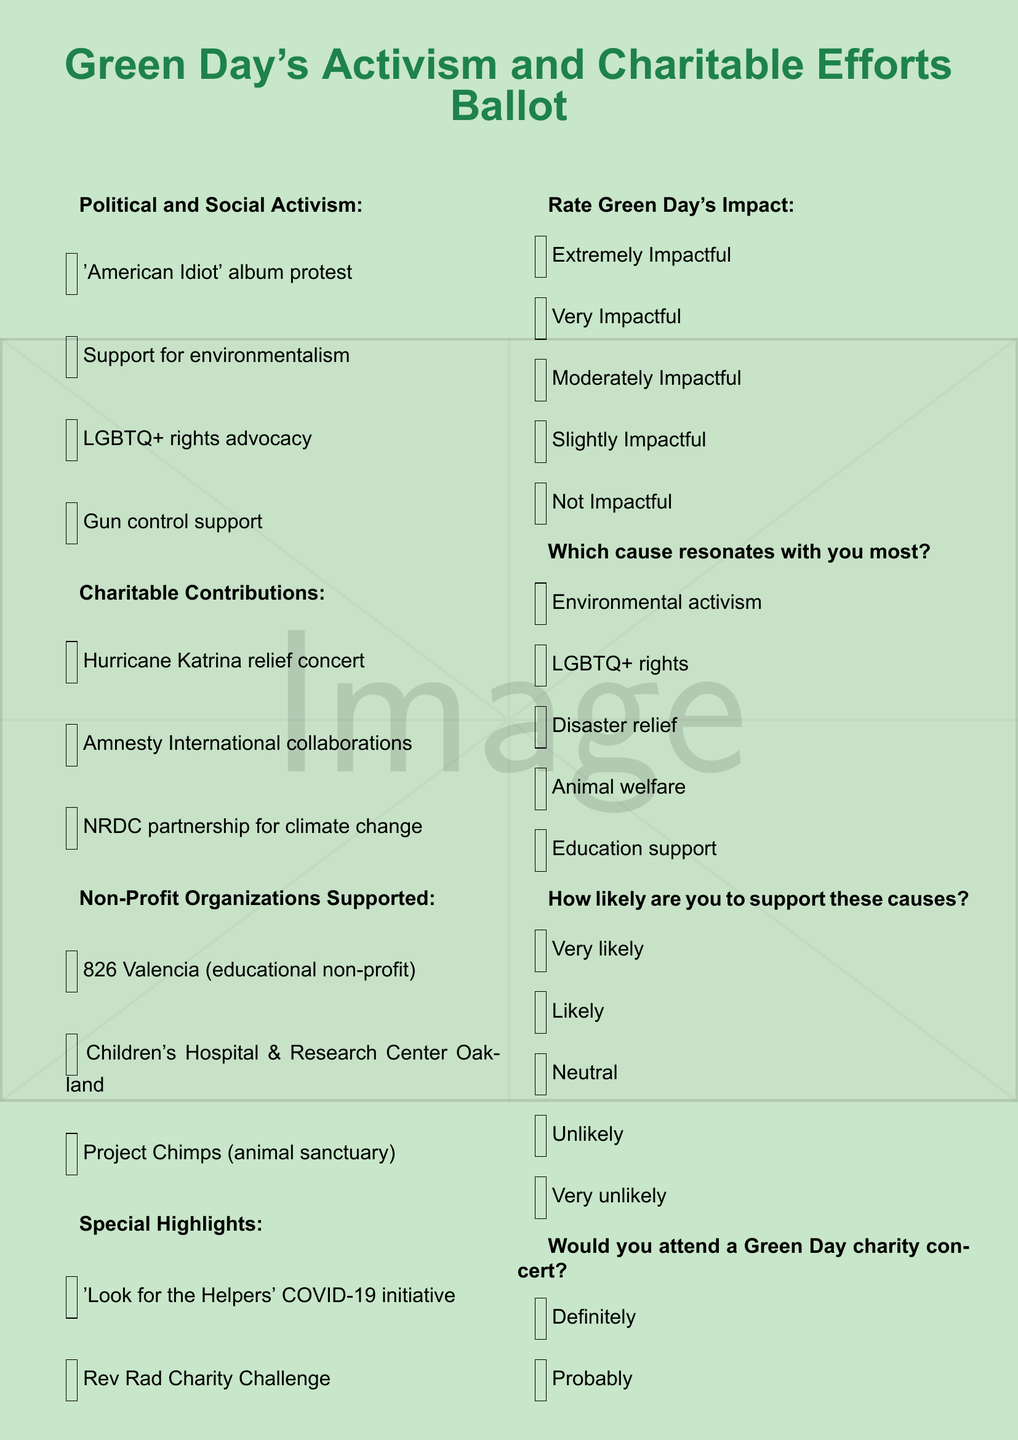What is the title of the document? The title is presented at the top of the document, indicating the primary focus on Green Day's activism and charitable efforts.
Answer: Green Day's Activism and Charitable Efforts Ballot How many non-profit organizations does Green Day support? The document lists three specific non-profit organizations under the "Non-Profit Organizations Supported" section.
Answer: 3 Which album by Green Day is mentioned in relation to protest? The document mentions a specific album in the context of political activism and protest efforts.
Answer: American Idiot What initiative did Green Day undertake during the COVID-19 pandemic? The document highlights a specific initiative launched by Green Day to address challenges during the pandemic.
Answer: Look for the Helpers What rating option indicates the highest perceived impact of Green Day's activism? The ballot provides several rating options for people to evaluate the band's impact, starting with the most impactful.
Answer: Extremely Impactful How many categories of contributions are highlighted in the ballot? The document organizes the contributions into distinct categories which provide clarity on Green Day's activism and charitable actions.
Answer: 4 Which cause is listed under "Which cause resonates with you most?" The document provides a selection of causes, presenting them to the reader for consideration based on personal resonance.
Answer: Environmental activism What is the lowest likelihood response option for supporting causes? The document outlines a series of likelihood responses and includes the option with the least support.
Answer: Very unlikely 